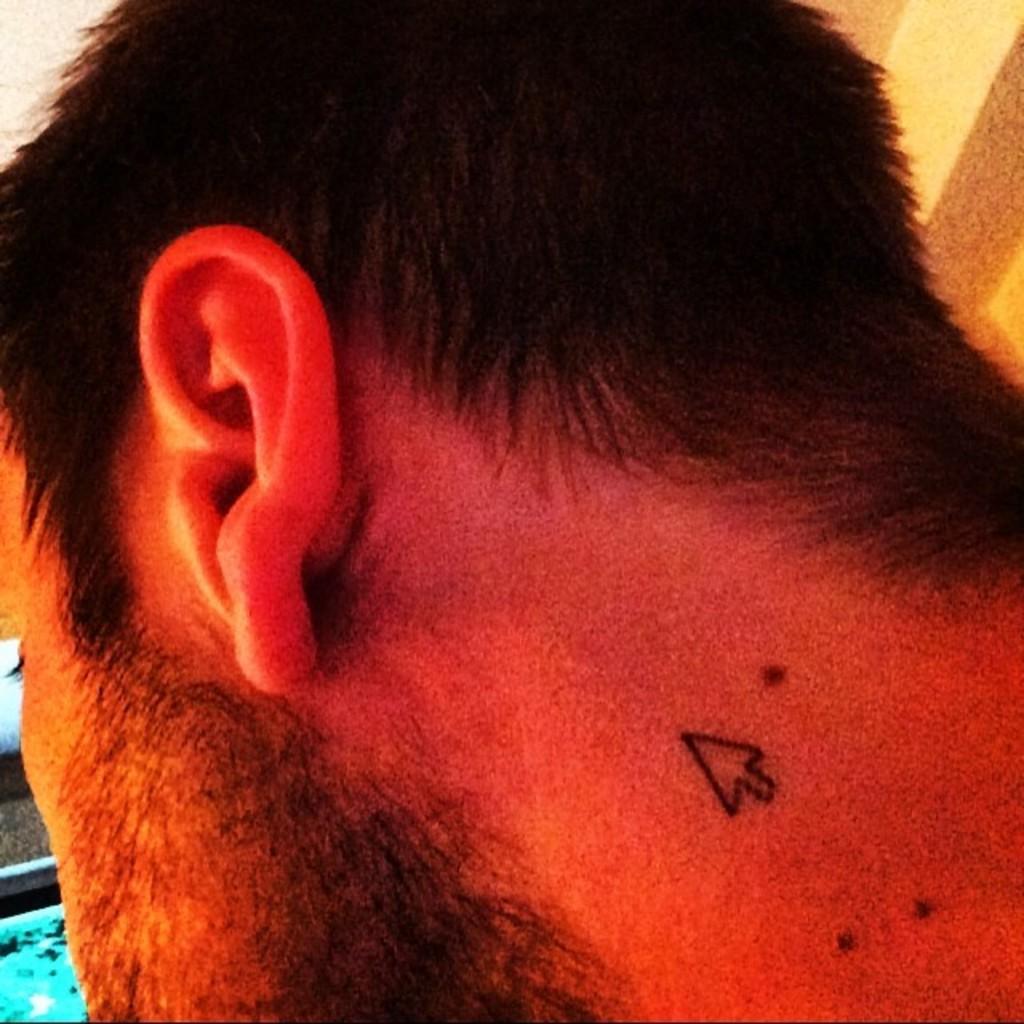Describe this image in one or two sentences. In this image, we can see a person. We can also some objects on the left. 